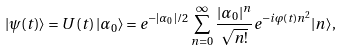Convert formula to latex. <formula><loc_0><loc_0><loc_500><loc_500>| \psi ( t ) \rangle = U \left ( t \right ) | \alpha _ { 0 } \rangle = e ^ { - | \alpha _ { 0 } | / 2 } \sum _ { n = 0 } ^ { \infty } \frac { | \alpha _ { 0 } | ^ { n } } { \sqrt { n ! } } e ^ { - i \varphi ( t ) n ^ { 2 } } | n \rangle ,</formula> 